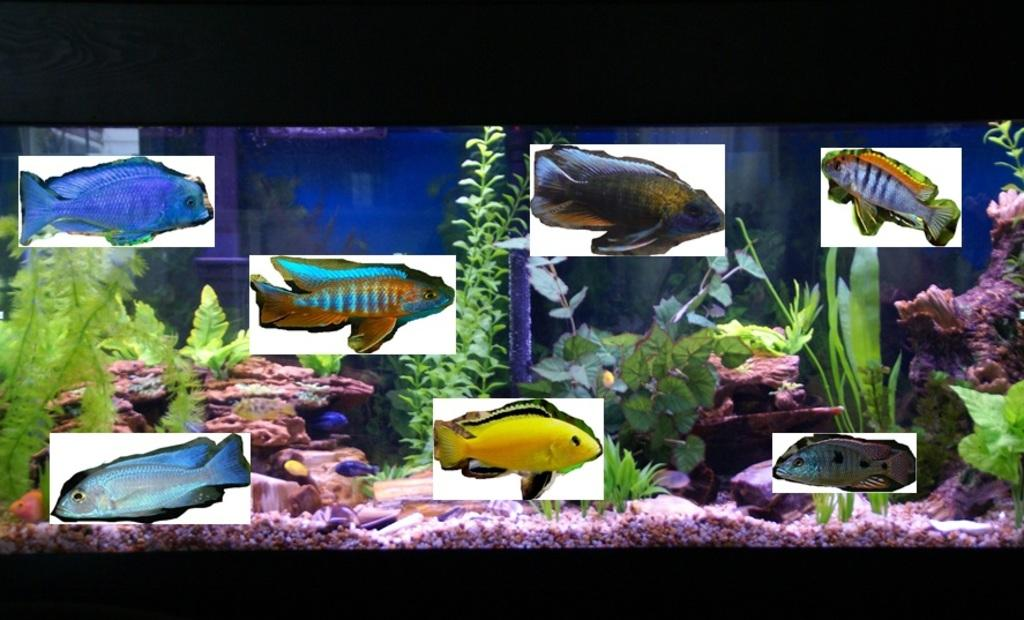What type of animals can be seen in the image? There are fishes in the image. Where are the fishes located? The fishes are in an aquarium. What else can be found in the aquarium besides the fishes? There are small plants and stones in the aquarium. What color is the water in the aquarium? The water in the aquarium is blue. What type of print can be seen on the seashore in the image? There is no seashore or print present in the image; it features an aquarium with fishes, small plants, stones, and blue water. 